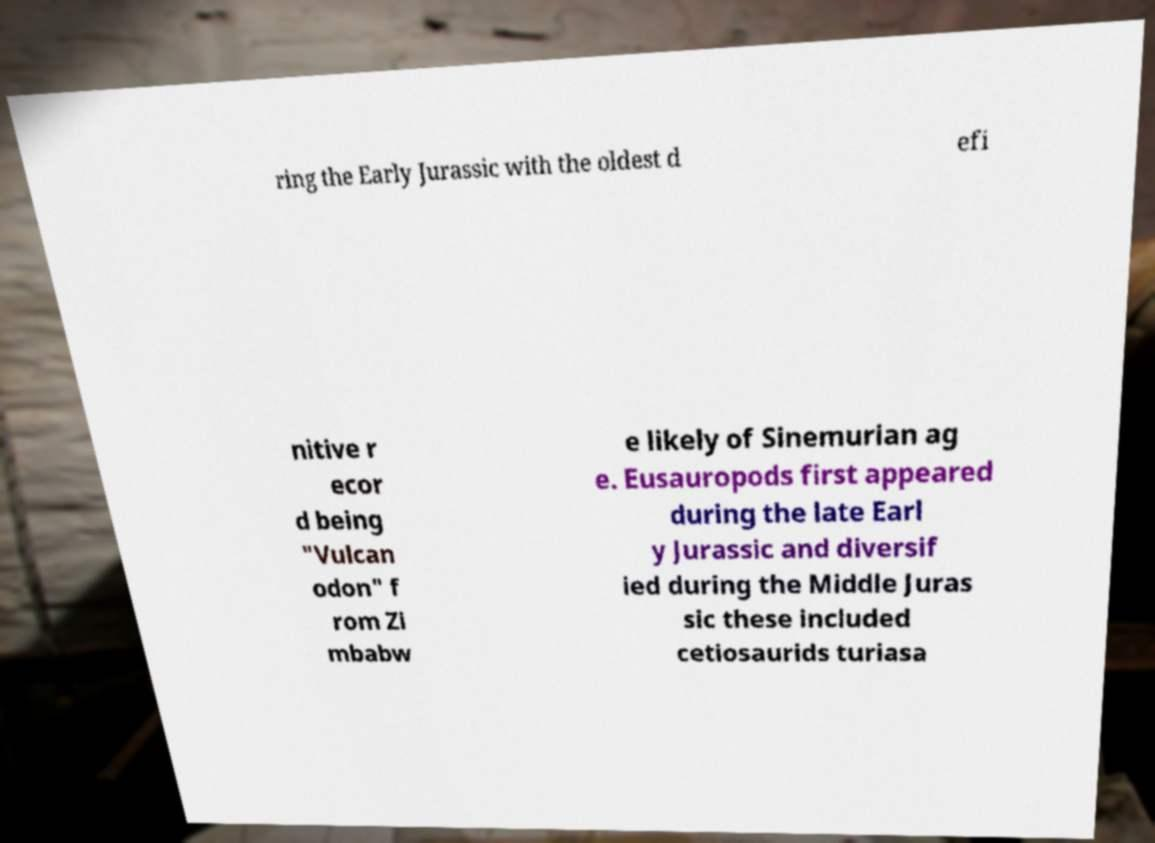Can you read and provide the text displayed in the image?This photo seems to have some interesting text. Can you extract and type it out for me? ring the Early Jurassic with the oldest d efi nitive r ecor d being "Vulcan odon" f rom Zi mbabw e likely of Sinemurian ag e. Eusauropods first appeared during the late Earl y Jurassic and diversif ied during the Middle Juras sic these included cetiosaurids turiasa 